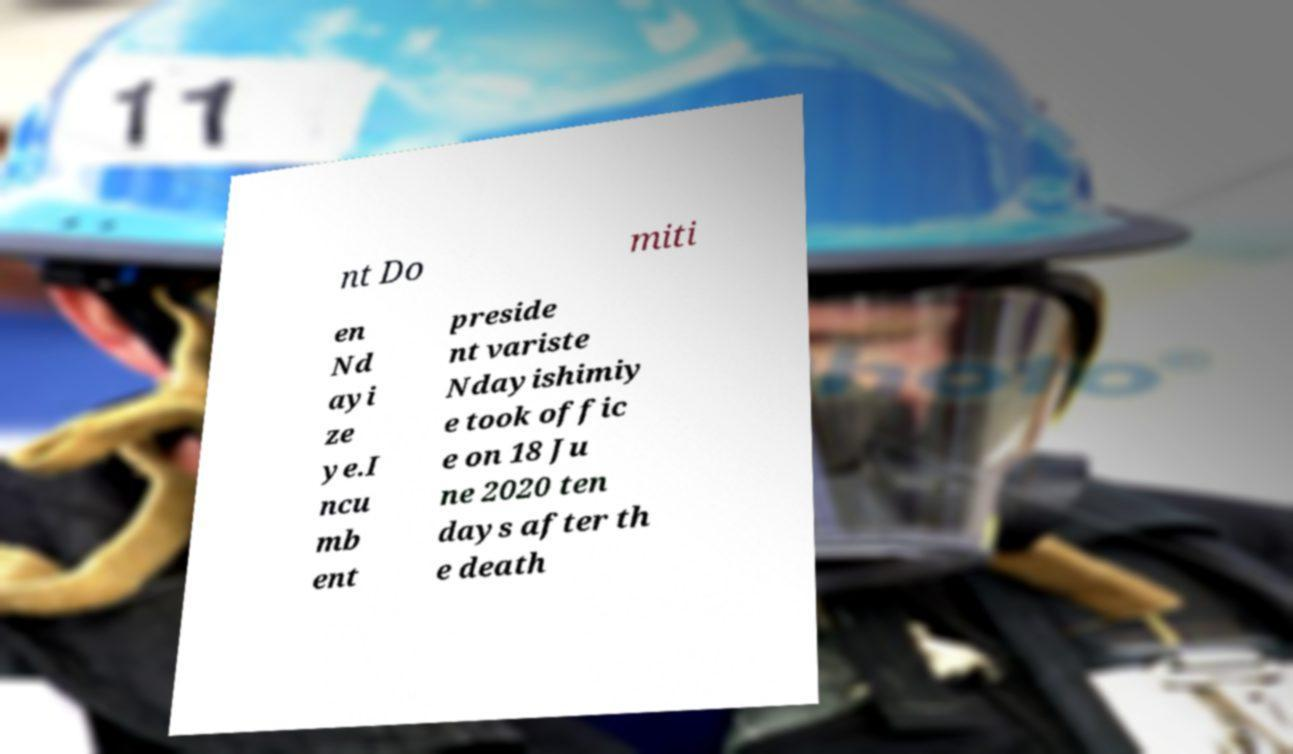There's text embedded in this image that I need extracted. Can you transcribe it verbatim? nt Do miti en Nd ayi ze ye.I ncu mb ent preside nt variste Ndayishimiy e took offic e on 18 Ju ne 2020 ten days after th e death 